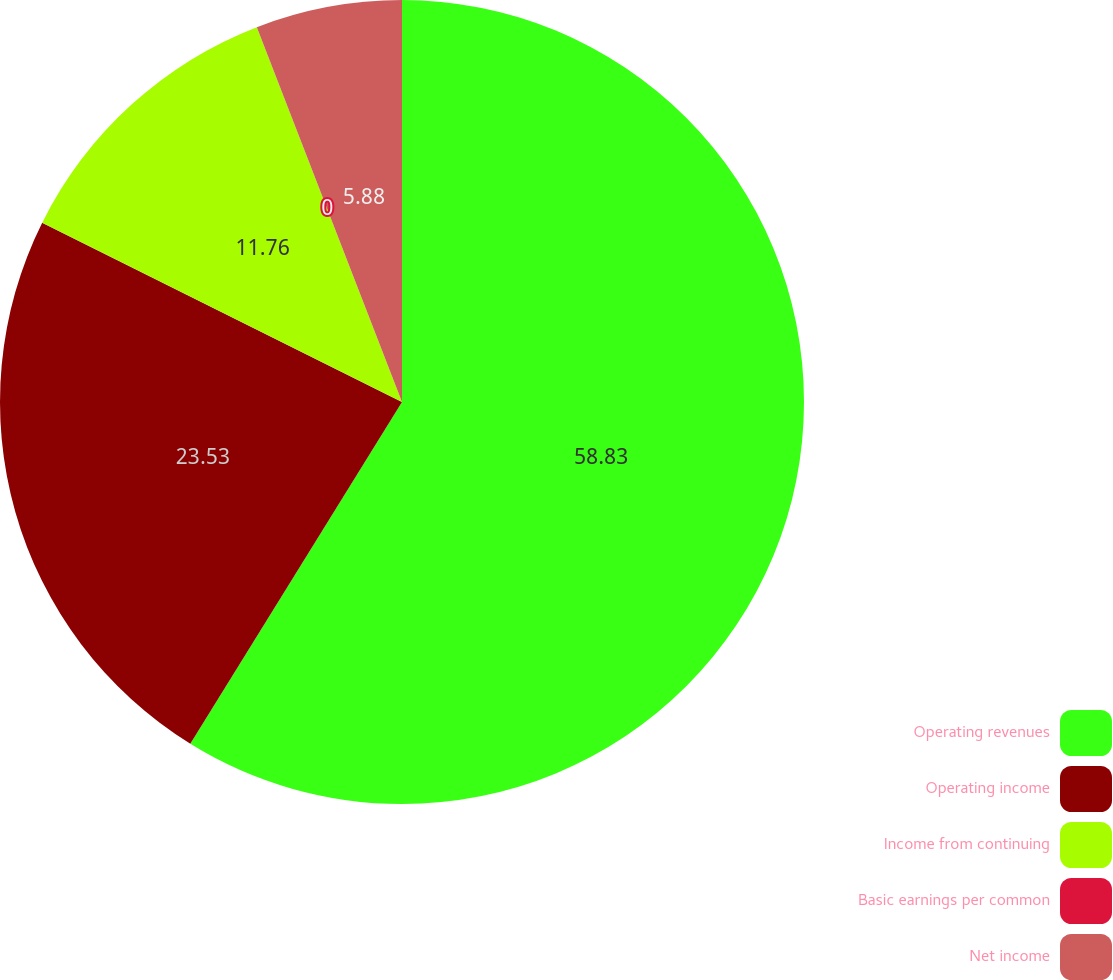Convert chart. <chart><loc_0><loc_0><loc_500><loc_500><pie_chart><fcel>Operating revenues<fcel>Operating income<fcel>Income from continuing<fcel>Basic earnings per common<fcel>Net income<nl><fcel>58.82%<fcel>23.53%<fcel>11.76%<fcel>0.0%<fcel>5.88%<nl></chart> 